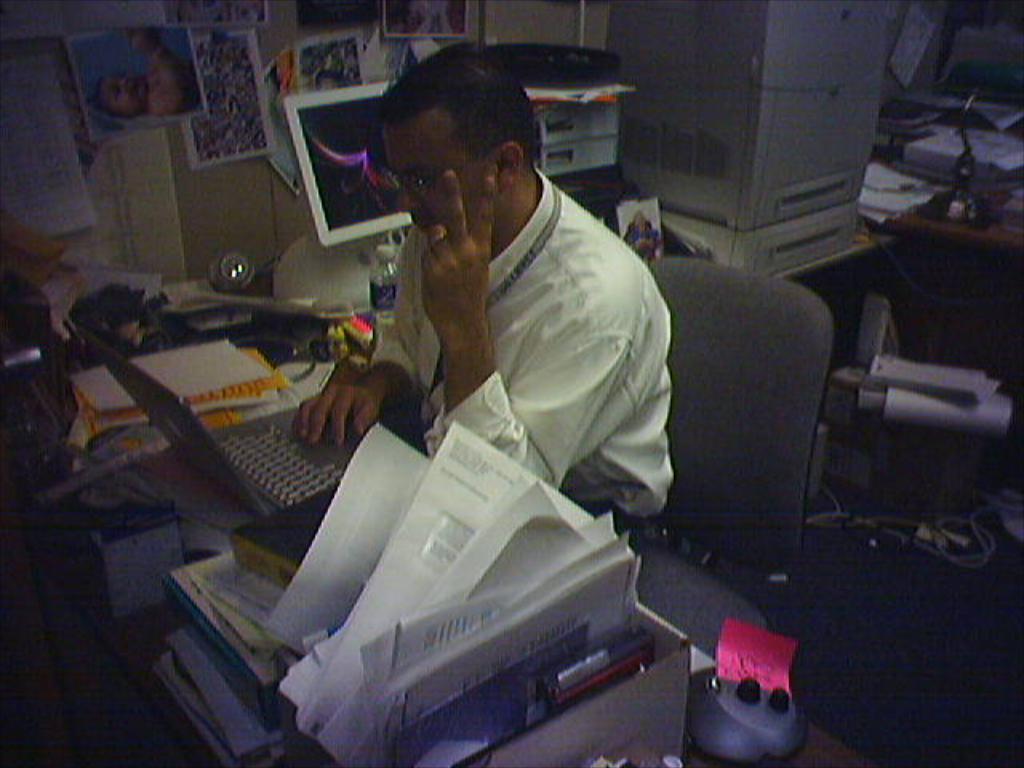Can you describe this image briefly? In this image, I can see a person sitting on a chair. In front of the person, I can see laptop, books, papers and few other objects on a table. In the background, I can see a monitor, machine, water bottle, few other things on a table and there are posters attached to the wall. On the right side of the image, I can see an object and cables on the floor and there are few objects on a table. 